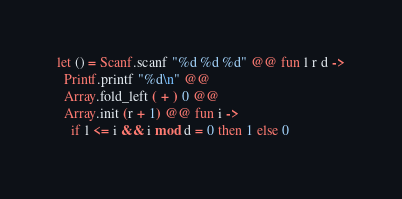Convert code to text. <code><loc_0><loc_0><loc_500><loc_500><_OCaml_>let () = Scanf.scanf "%d %d %d" @@ fun l r d ->
  Printf.printf "%d\n" @@
  Array.fold_left ( + ) 0 @@
  Array.init (r + 1) @@ fun i ->
    if l <= i && i mod d = 0 then 1 else 0</code> 